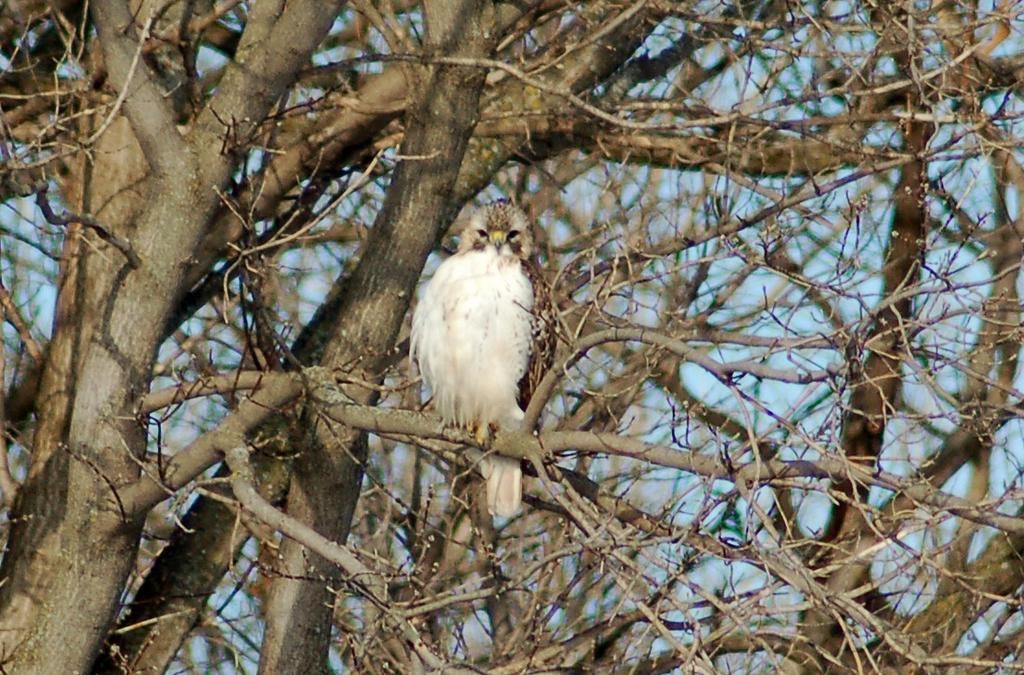What type of animal can be seen in the image? There is a bird in the image. Where is the bird located? The bird is on a branch in the image. What type of vegetation is present in the image? There are trees with branches and stems in the image. What type of collar can be seen on the bird in the image? There is no collar present on the bird in the image. Is the bird begging for food in the image? There is no indication in the image that the bird is begging for food. 